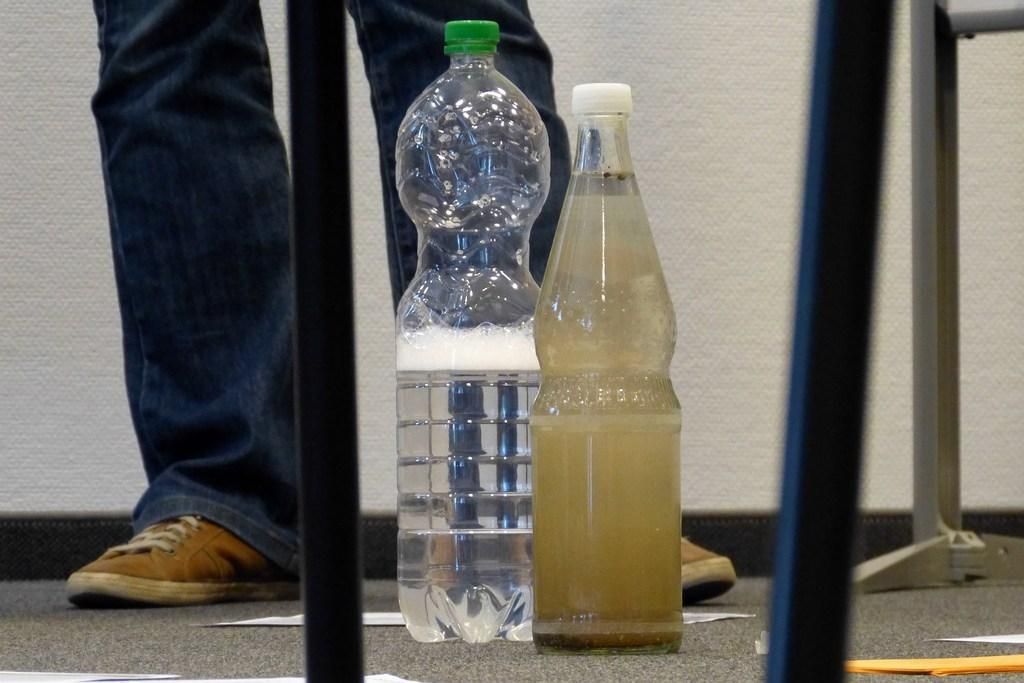How many bottles are visible in the image? There are two bottles in the image. What is the difference between the contents of the two bottles? One bottle contains pure water, while the other bottle contains dirty water. Can you describe the person in the background of the image? There is a person wearing blue jeans in the background of the image. What type of bag is the person carrying on their back in the image? There is no person carrying a bag on their back in the image. What reward can be seen for collecting all the dirty water bottles in the image? There is no reward visible in the image for collecting dirty water bottles. 